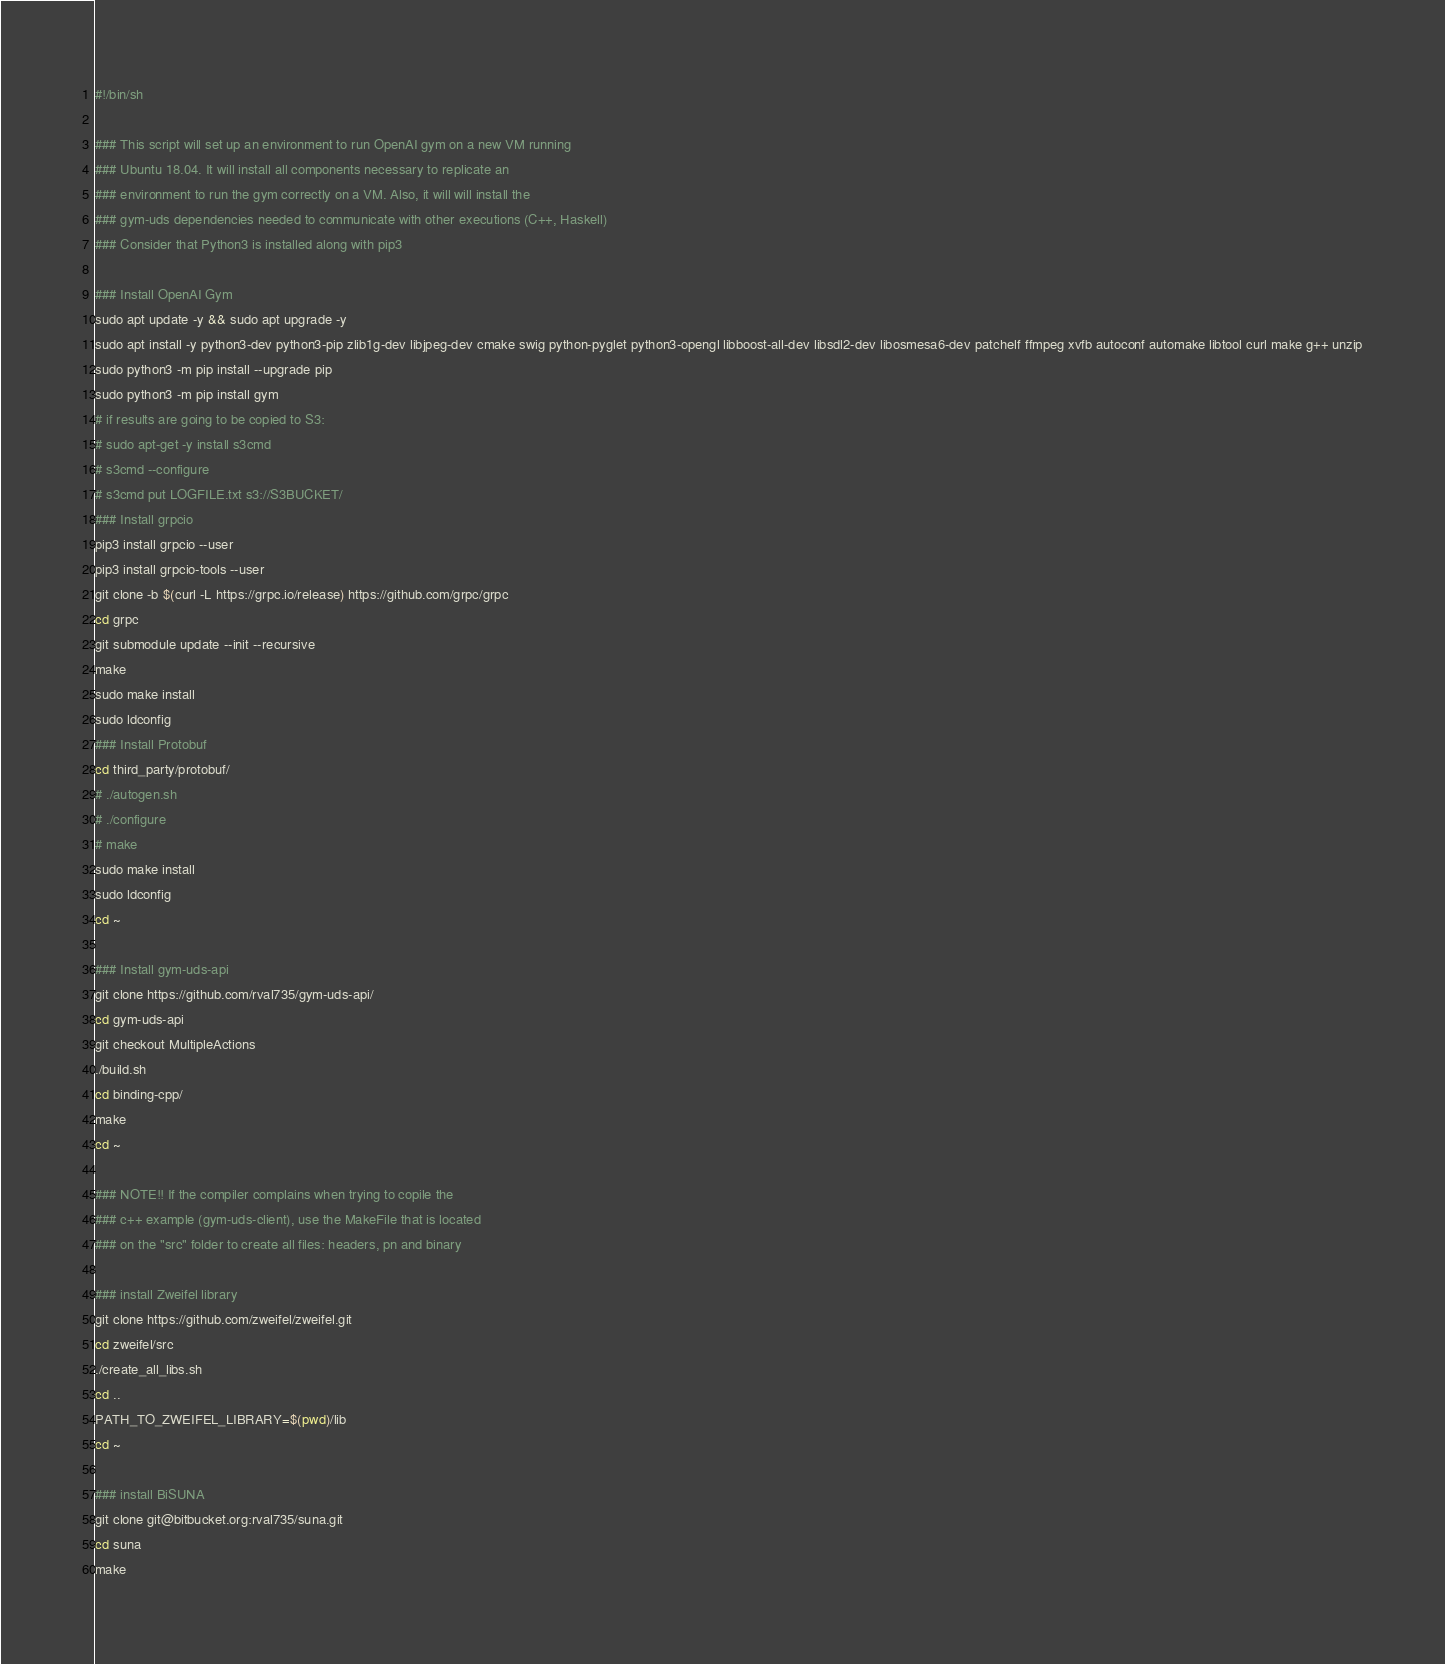<code> <loc_0><loc_0><loc_500><loc_500><_Bash_>#!/bin/sh

### This script will set up an environment to run OpenAI gym on a new VM running
### Ubuntu 18.04. It will install all components necessary to replicate an
### environment to run the gym correctly on a VM. Also, it will will install the
### gym-uds dependencies needed to communicate with other executions (C++, Haskell)
### Consider that Python3 is installed along with pip3

### Install OpenAI Gym
sudo apt update -y && sudo apt upgrade -y
sudo apt install -y python3-dev python3-pip zlib1g-dev libjpeg-dev cmake swig python-pyglet python3-opengl libboost-all-dev libsdl2-dev libosmesa6-dev patchelf ffmpeg xvfb autoconf automake libtool curl make g++ unzip
sudo python3 -m pip install --upgrade pip
sudo python3 -m pip install gym
# if results are going to be copied to S3:
# sudo apt-get -y install s3cmd
# s3cmd --configure
# s3cmd put LOGFILE.txt s3://S3BUCKET/
### Install grpcio
pip3 install grpcio --user
pip3 install grpcio-tools --user
git clone -b $(curl -L https://grpc.io/release) https://github.com/grpc/grpc
cd grpc
git submodule update --init --recursive
make
sudo make install
sudo ldconfig
### Install Protobuf
cd third_party/protobuf/
# ./autogen.sh
# ./configure
# make
sudo make install
sudo ldconfig
cd ~

### Install gym-uds-api
git clone https://github.com/rval735/gym-uds-api/
cd gym-uds-api
git checkout MultipleActions
./build.sh
cd binding-cpp/
make
cd ~

### NOTE!! If the compiler complains when trying to copile the
### c++ example (gym-uds-client), use the MakeFile that is located
### on the "src" folder to create all files: headers, pn and binary

### install Zweifel library
git clone https://github.com/zweifel/zweifel.git
cd zweifel/src
./create_all_libs.sh
cd ..
PATH_TO_ZWEIFEL_LIBRARY=$(pwd)/lib
cd ~

### install BiSUNA
git clone git@bitbucket.org:rval735/suna.git
cd suna
make</code> 